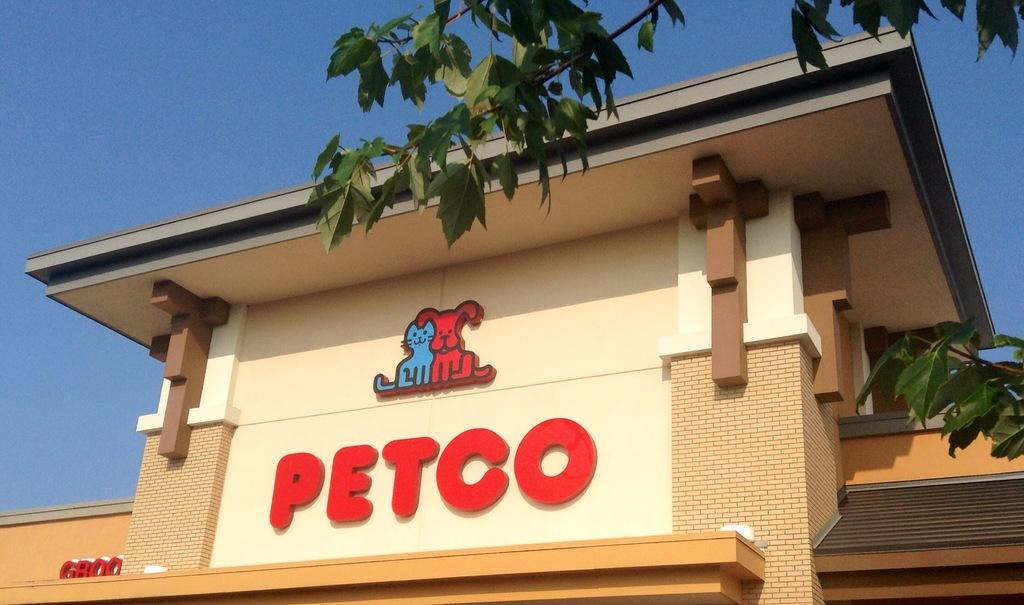What type of structure is present in the image? There is a building in the image. What can be seen on the building? The building has names and animal symbols on it. What other elements are present in the image? There is a tree in the image. What can be seen in the background of the image? The sky is visible in the background of the image. How many people are in the crowd gathered around the building in the image? There is no crowd present in the image; it only shows the building, names, animal symbols, a tree, and the sky. 